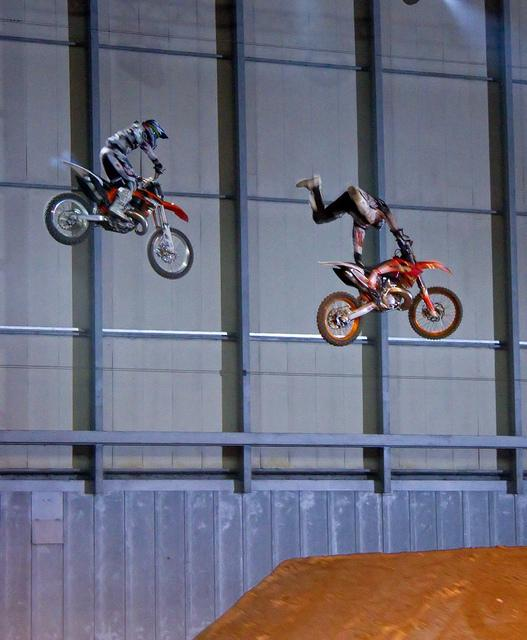What mechanism the the motorcyclists just engage? Please explain your reasoning. ramp. The motorcyclists are going up a ramp. 